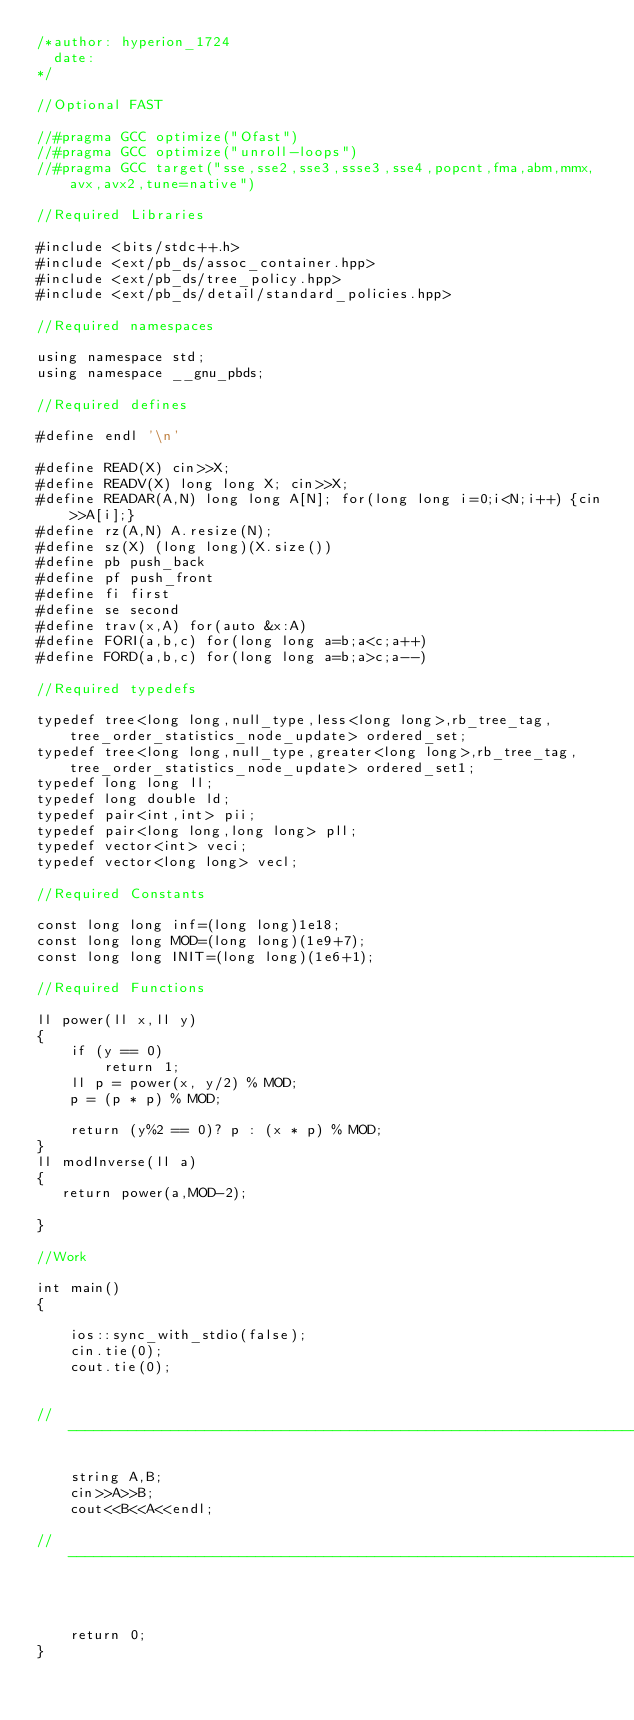<code> <loc_0><loc_0><loc_500><loc_500><_C++_>/*author: hyperion_1724
  date: 
*/

//Optional FAST

//#pragma GCC optimize("Ofast")
//#pragma GCC optimize("unroll-loops")
//#pragma GCC target("sse,sse2,sse3,ssse3,sse4,popcnt,fma,abm,mmx,avx,avx2,tune=native")

//Required Libraries

#include <bits/stdc++.h>
#include <ext/pb_ds/assoc_container.hpp>
#include <ext/pb_ds/tree_policy.hpp>
#include <ext/pb_ds/detail/standard_policies.hpp>

//Required namespaces

using namespace std;
using namespace __gnu_pbds;

//Required defines

#define endl '\n'

#define READ(X) cin>>X;
#define READV(X) long long X; cin>>X;
#define READAR(A,N) long long A[N]; for(long long i=0;i<N;i++) {cin>>A[i];}
#define rz(A,N) A.resize(N);
#define sz(X) (long long)(X.size())
#define pb push_back
#define pf push_front
#define fi first
#define se second
#define trav(x,A) for(auto &x:A)
#define FORI(a,b,c) for(long long a=b;a<c;a++)
#define FORD(a,b,c) for(long long a=b;a>c;a--)

//Required typedefs

typedef tree<long long,null_type,less<long long>,rb_tree_tag,tree_order_statistics_node_update> ordered_set;
typedef tree<long long,null_type,greater<long long>,rb_tree_tag,tree_order_statistics_node_update> ordered_set1;
typedef long long ll;
typedef long double ld;
typedef pair<int,int> pii;
typedef pair<long long,long long> pll;
typedef vector<int> veci;
typedef vector<long long> vecl;

//Required Constants

const long long inf=(long long)1e18;
const long long MOD=(long long)(1e9+7);
const long long INIT=(long long)(1e6+1);

//Required Functions

ll power(ll x,ll y) 
{ 
    if (y == 0) 
        return 1; 
    ll p = power(x, y/2) % MOD; 
    p = (p * p) % MOD; 
  
    return (y%2 == 0)? p : (x * p) % MOD; 
}
ll modInverse(ll a) 
{ 
   return power(a,MOD-2); 
   
}

//Work

int main()
{
   
    ios::sync_with_stdio(false);
    cin.tie(0);
    cout.tie(0);

    
//-----------------------------------------------------------------------------------------------------------//

    string A,B;
    cin>>A>>B;
    cout<<B<<A<<endl;

//-----------------------------------------------------------------------------------------------------------//


  
    return 0;
}</code> 